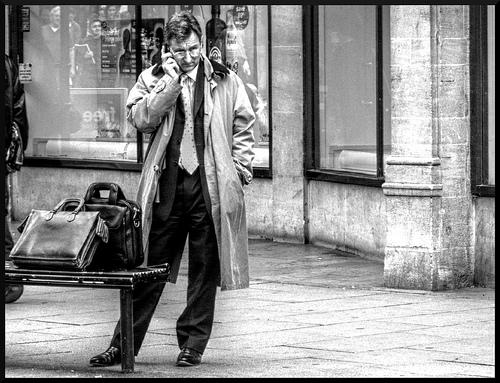What is on the bench?
Be succinct. Briefcases. What is the man holding in his right hand?
Be succinct. Cell phone. Is this a farm?
Short answer required. No. Is this man using a tie tack?
Give a very brief answer. No. 